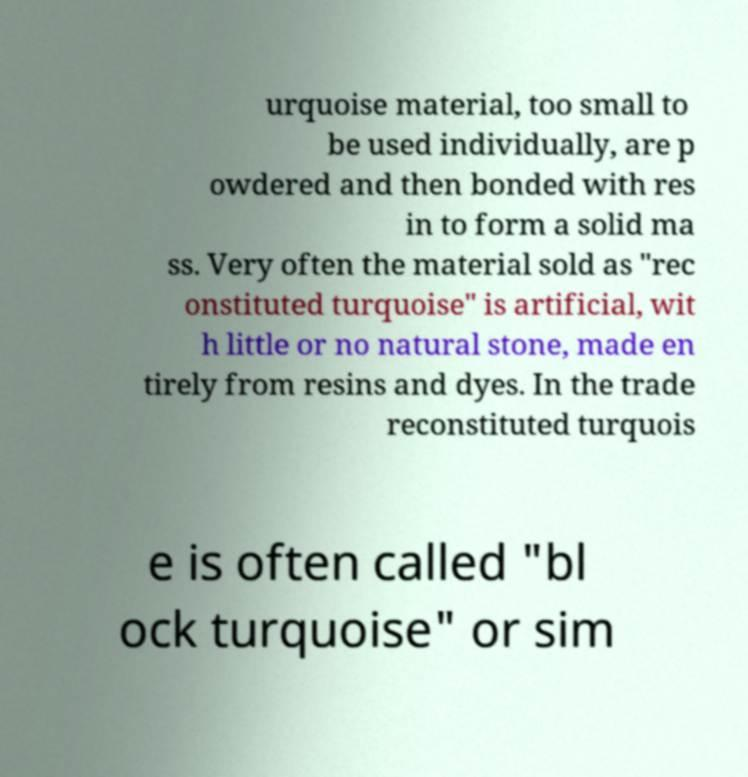Can you accurately transcribe the text from the provided image for me? urquoise material, too small to be used individually, are p owdered and then bonded with res in to form a solid ma ss. Very often the material sold as "rec onstituted turquoise" is artificial, wit h little or no natural stone, made en tirely from resins and dyes. In the trade reconstituted turquois e is often called "bl ock turquoise" or sim 